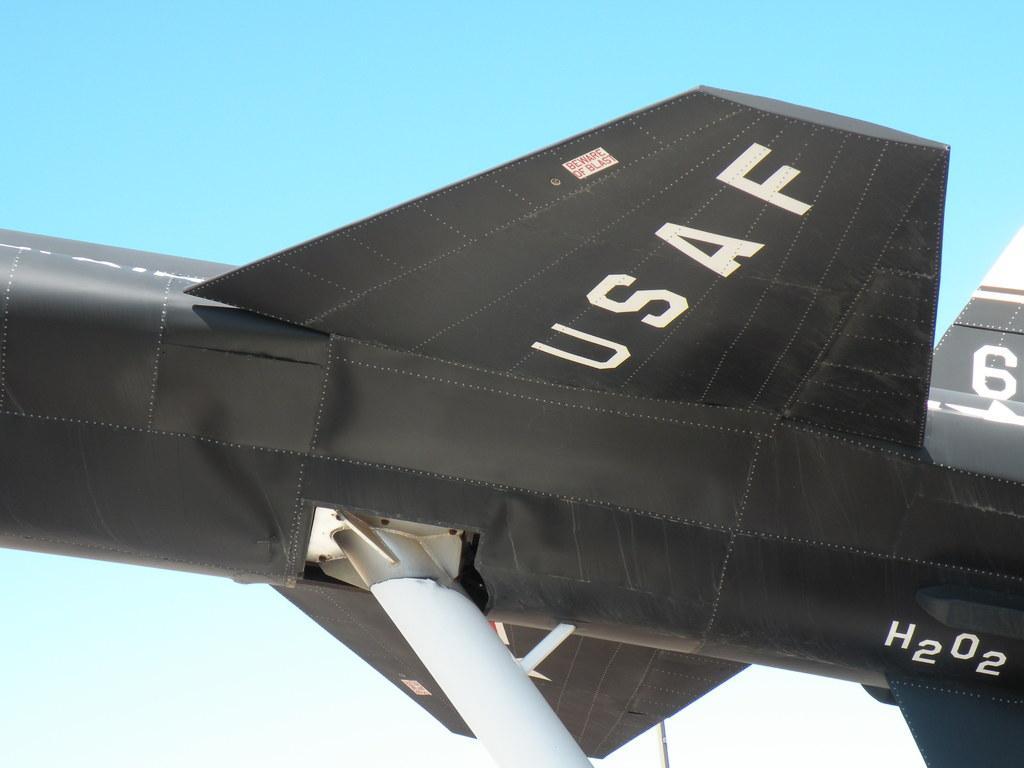Please provide a concise description of this image. This image consists of an aircraft. In black color. In the background, there is the sky. And we can see the text on the aircraft. 